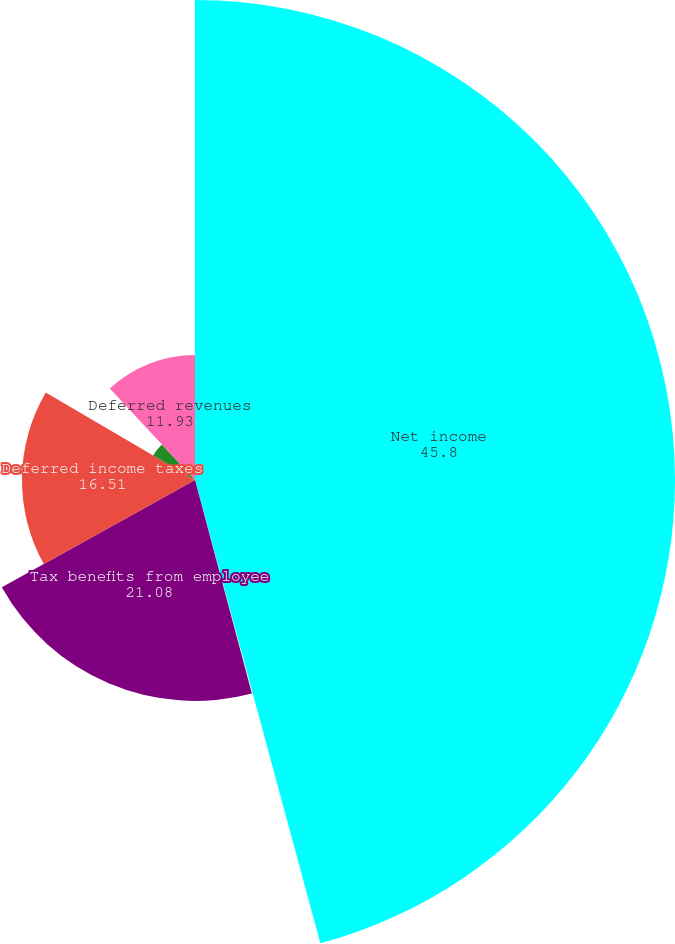<chart> <loc_0><loc_0><loc_500><loc_500><pie_chart><fcel>Net income<fcel>Stock-based compensation<fcel>Tax benefits from employee<fcel>Deferred income taxes<fcel>Accounts payable and accrued<fcel>Deferred revenues<nl><fcel>45.8%<fcel>0.06%<fcel>21.08%<fcel>16.51%<fcel>4.63%<fcel>11.93%<nl></chart> 